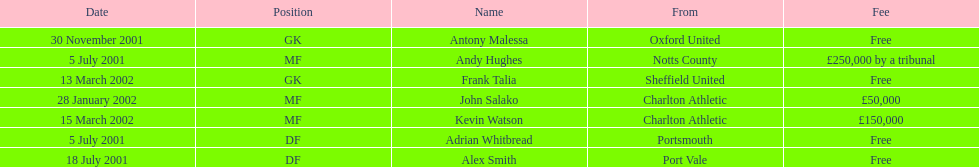Andy huges and adrian whitbread both tranfered on which date? 5 July 2001. Would you be able to parse every entry in this table? {'header': ['Date', 'Position', 'Name', 'From', 'Fee'], 'rows': [['30 November 2001', 'GK', 'Antony Malessa', 'Oxford United', 'Free'], ['5 July 2001', 'MF', 'Andy Hughes', 'Notts County', '£250,000 by a tribunal'], ['13 March 2002', 'GK', 'Frank Talia', 'Sheffield United', 'Free'], ['28 January 2002', 'MF', 'John Salako', 'Charlton Athletic', '£50,000'], ['15 March 2002', 'MF', 'Kevin Watson', 'Charlton Athletic', '£150,000'], ['5 July 2001', 'DF', 'Adrian Whitbread', 'Portsmouth', 'Free'], ['18 July 2001', 'DF', 'Alex Smith', 'Port Vale', 'Free']]} 